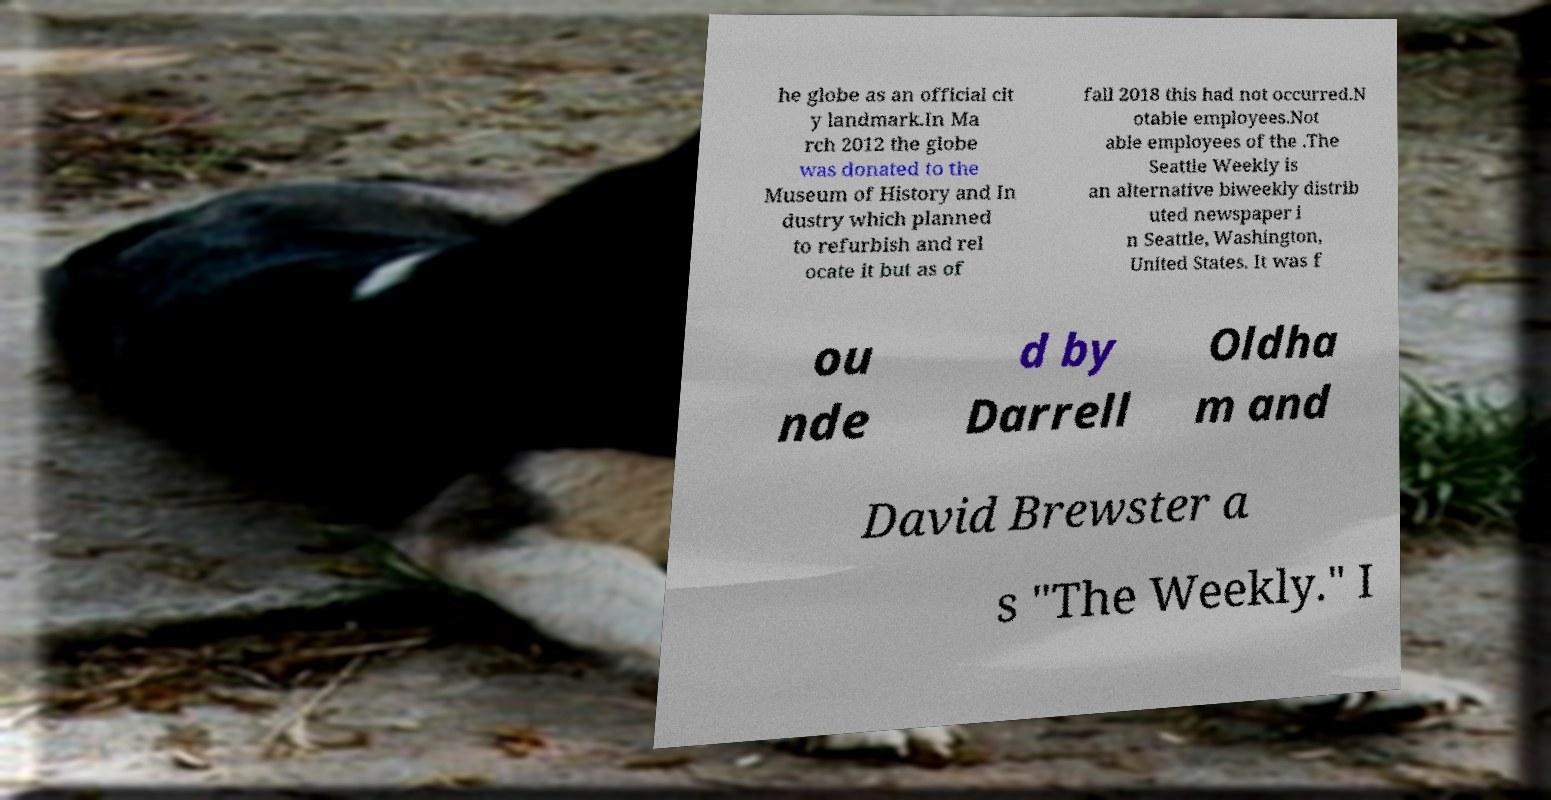Can you read and provide the text displayed in the image?This photo seems to have some interesting text. Can you extract and type it out for me? he globe as an official cit y landmark.In Ma rch 2012 the globe was donated to the Museum of History and In dustry which planned to refurbish and rel ocate it but as of fall 2018 this had not occurred.N otable employees.Not able employees of the .The Seattle Weekly is an alternative biweekly distrib uted newspaper i n Seattle, Washington, United States. It was f ou nde d by Darrell Oldha m and David Brewster a s "The Weekly." I 